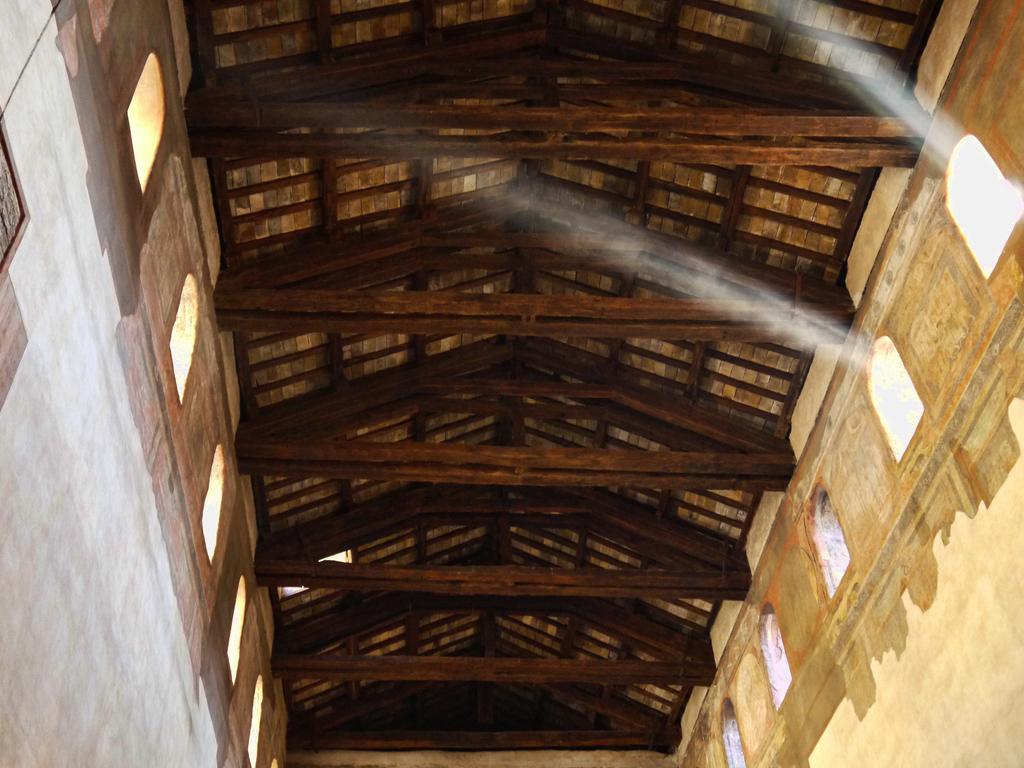Can you describe this image briefly? In this picture we can see the rooftop of a room. The roof top is made of wood and beams. 